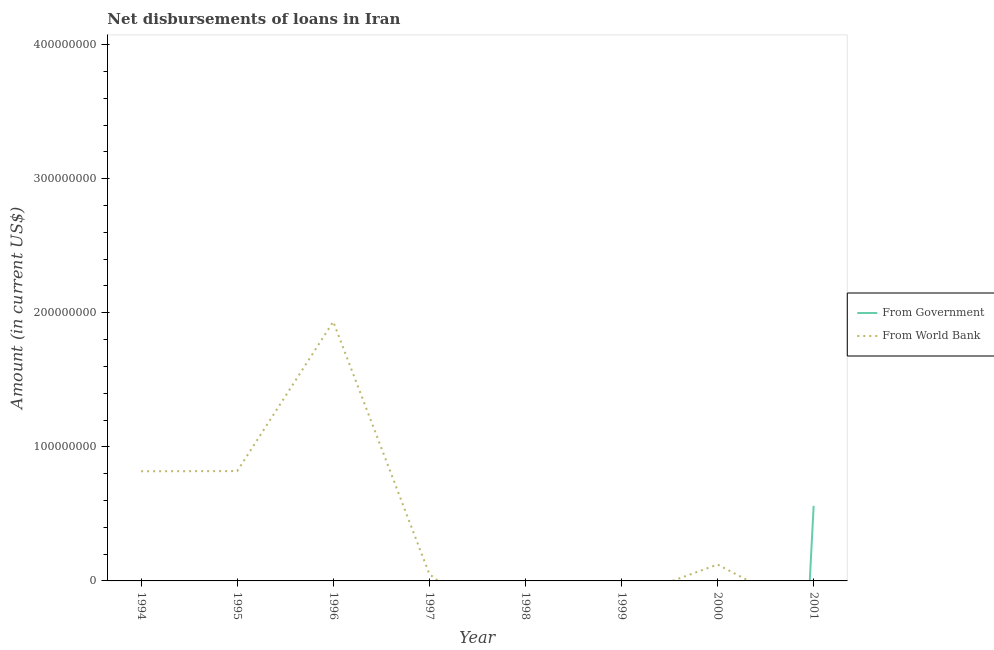How many different coloured lines are there?
Keep it short and to the point. 2. Does the line corresponding to net disbursements of loan from world bank intersect with the line corresponding to net disbursements of loan from government?
Keep it short and to the point. Yes. What is the net disbursements of loan from government in 1995?
Your response must be concise. 0. Across all years, what is the maximum net disbursements of loan from government?
Make the answer very short. 5.60e+07. Across all years, what is the minimum net disbursements of loan from world bank?
Offer a terse response. 0. In which year was the net disbursements of loan from world bank maximum?
Your response must be concise. 1996. What is the total net disbursements of loan from government in the graph?
Offer a terse response. 5.60e+07. What is the difference between the net disbursements of loan from world bank in 1997 and that in 2000?
Give a very brief answer. -7.12e+06. What is the difference between the net disbursements of loan from world bank in 1995 and the net disbursements of loan from government in 2001?
Keep it short and to the point. 2.59e+07. What is the average net disbursements of loan from world bank per year?
Your answer should be very brief. 4.68e+07. What is the ratio of the net disbursements of loan from world bank in 1994 to that in 1995?
Provide a succinct answer. 1. What is the difference between the highest and the second highest net disbursements of loan from world bank?
Your answer should be compact. 1.11e+08. What is the difference between the highest and the lowest net disbursements of loan from world bank?
Offer a very short reply. 1.93e+08. In how many years, is the net disbursements of loan from world bank greater than the average net disbursements of loan from world bank taken over all years?
Your answer should be compact. 3. Is the net disbursements of loan from world bank strictly less than the net disbursements of loan from government over the years?
Your answer should be very brief. No. Does the graph contain grids?
Offer a very short reply. No. Where does the legend appear in the graph?
Keep it short and to the point. Center right. How many legend labels are there?
Your response must be concise. 2. How are the legend labels stacked?
Provide a short and direct response. Vertical. What is the title of the graph?
Provide a succinct answer. Net disbursements of loans in Iran. Does "Merchandise exports" appear as one of the legend labels in the graph?
Offer a very short reply. No. What is the label or title of the Y-axis?
Offer a terse response. Amount (in current US$). What is the Amount (in current US$) of From Government in 1994?
Your response must be concise. 0. What is the Amount (in current US$) in From World Bank in 1994?
Provide a succinct answer. 8.18e+07. What is the Amount (in current US$) of From World Bank in 1995?
Keep it short and to the point. 8.19e+07. What is the Amount (in current US$) in From World Bank in 1996?
Provide a succinct answer. 1.93e+08. What is the Amount (in current US$) of From World Bank in 1997?
Your answer should be very brief. 5.11e+06. What is the Amount (in current US$) in From Government in 1998?
Your answer should be compact. 0. What is the Amount (in current US$) of From World Bank in 1998?
Make the answer very short. 0. What is the Amount (in current US$) of From Government in 1999?
Give a very brief answer. 0. What is the Amount (in current US$) of From World Bank in 1999?
Your answer should be very brief. 0. What is the Amount (in current US$) in From Government in 2000?
Provide a short and direct response. 0. What is the Amount (in current US$) in From World Bank in 2000?
Your answer should be very brief. 1.22e+07. What is the Amount (in current US$) in From Government in 2001?
Your answer should be compact. 5.60e+07. What is the Amount (in current US$) of From World Bank in 2001?
Your answer should be compact. 0. Across all years, what is the maximum Amount (in current US$) in From Government?
Offer a very short reply. 5.60e+07. Across all years, what is the maximum Amount (in current US$) of From World Bank?
Your answer should be very brief. 1.93e+08. Across all years, what is the minimum Amount (in current US$) in From World Bank?
Ensure brevity in your answer.  0. What is the total Amount (in current US$) of From Government in the graph?
Give a very brief answer. 5.60e+07. What is the total Amount (in current US$) in From World Bank in the graph?
Your answer should be compact. 3.74e+08. What is the difference between the Amount (in current US$) of From World Bank in 1994 and that in 1995?
Offer a terse response. -1.22e+05. What is the difference between the Amount (in current US$) in From World Bank in 1994 and that in 1996?
Ensure brevity in your answer.  -1.12e+08. What is the difference between the Amount (in current US$) of From World Bank in 1994 and that in 1997?
Give a very brief answer. 7.67e+07. What is the difference between the Amount (in current US$) of From World Bank in 1994 and that in 2000?
Offer a terse response. 6.96e+07. What is the difference between the Amount (in current US$) of From World Bank in 1995 and that in 1996?
Provide a succinct answer. -1.11e+08. What is the difference between the Amount (in current US$) of From World Bank in 1995 and that in 1997?
Make the answer very short. 7.68e+07. What is the difference between the Amount (in current US$) in From World Bank in 1995 and that in 2000?
Provide a short and direct response. 6.97e+07. What is the difference between the Amount (in current US$) of From World Bank in 1996 and that in 1997?
Your response must be concise. 1.88e+08. What is the difference between the Amount (in current US$) in From World Bank in 1996 and that in 2000?
Your answer should be very brief. 1.81e+08. What is the difference between the Amount (in current US$) in From World Bank in 1997 and that in 2000?
Your answer should be very brief. -7.12e+06. What is the average Amount (in current US$) in From Government per year?
Your answer should be very brief. 7.00e+06. What is the average Amount (in current US$) in From World Bank per year?
Give a very brief answer. 4.68e+07. What is the ratio of the Amount (in current US$) of From World Bank in 1994 to that in 1996?
Offer a terse response. 0.42. What is the ratio of the Amount (in current US$) in From World Bank in 1994 to that in 1997?
Give a very brief answer. 16.01. What is the ratio of the Amount (in current US$) of From World Bank in 1994 to that in 2000?
Give a very brief answer. 6.69. What is the ratio of the Amount (in current US$) of From World Bank in 1995 to that in 1996?
Your answer should be very brief. 0.42. What is the ratio of the Amount (in current US$) of From World Bank in 1995 to that in 1997?
Provide a short and direct response. 16.04. What is the ratio of the Amount (in current US$) in From World Bank in 1995 to that in 2000?
Your response must be concise. 6.7. What is the ratio of the Amount (in current US$) of From World Bank in 1996 to that in 1997?
Offer a terse response. 37.86. What is the ratio of the Amount (in current US$) in From World Bank in 1996 to that in 2000?
Provide a short and direct response. 15.82. What is the ratio of the Amount (in current US$) in From World Bank in 1997 to that in 2000?
Provide a short and direct response. 0.42. What is the difference between the highest and the second highest Amount (in current US$) of From World Bank?
Offer a terse response. 1.11e+08. What is the difference between the highest and the lowest Amount (in current US$) in From Government?
Offer a terse response. 5.60e+07. What is the difference between the highest and the lowest Amount (in current US$) in From World Bank?
Give a very brief answer. 1.93e+08. 